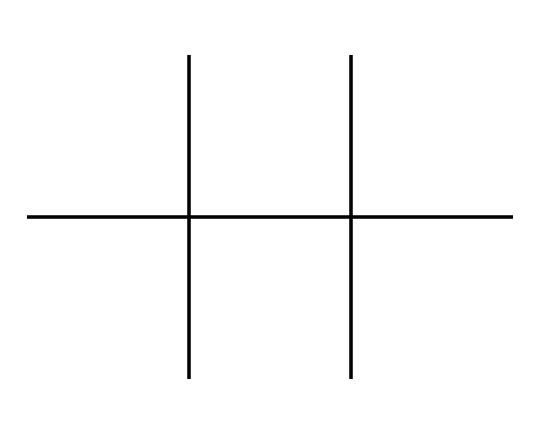What is the molecular formula of this chemical? To determine the molecular formula, count the carbon and hydrogen atoms represented in the SMILES. The structure indicates there are 8 carbon atoms and 18 hydrogen atoms. Thus, the molecular formula is C8H18.
Answer: C8H18 How many tertiary carbon atoms are present in this molecule? Tertiary carbon atoms are those carbon atoms bonded to three other carbon atoms. In the structure, there are 6 carbon atoms that fit this definition.
Answer: 6 What type of isomers are represented in this chemical? The structure is a form of octane, which can exhibit geometric isomerism due to its branching. This molecule shows structural isomerism because it has various branch arrangements.
Answer: structural isomers Does this chemical have geometric isomers? Geometric isomers require a double bond or ring structure to exist, which allows for different spatial arrangements of groups. The given molecule is fully saturated, excluding the possibility of geometric isomers.
Answer: no How many hydrogen atoms are connected to the terminal carbon atoms in this structure? A terminal carbon atom in a branched alkane typically has three hydrogen atoms. In this molecule, there are 2 terminal carbon atoms, each contributing 3 hydrogen atoms, leading to a total of 6 hydrogen atoms.
Answer: 6 Is this molecule a straight-chain or branched alkane? The structure depicts a branched arrangement due to the presence of side chains off the main carbon backbone. This confirms that the molecule is not a straight-chain alkane.
Answer: branched 